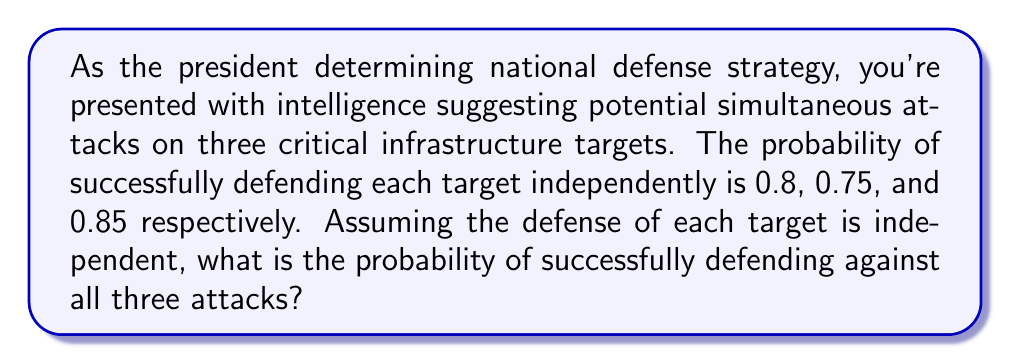Teach me how to tackle this problem. To solve this problem, we need to follow these steps:

1. Identify the given probabilities:
   - Target 1: $P(D_1) = 0.8$
   - Target 2: $P(D_2) = 0.75$
   - Target 3: $P(D_3) = 0.85$

   Where $D_i$ represents the event of successfully defending target $i$.

2. Since we need to calculate the probability of successfully defending all three targets, and the events are independent, we can use the multiplication rule of probability.

3. The probability of all three events occurring simultaneously is:

   $$P(D_1 \cap D_2 \cap D_3) = P(D_1) \times P(D_2) \times P(D_3)$$

4. Substituting the given probabilities:

   $$P(D_1 \cap D_2 \cap D_3) = 0.8 \times 0.75 \times 0.85$$

5. Calculating the result:

   $$P(D_1 \cap D_2 \cap D_3) = 0.51$$

Therefore, the probability of successfully defending against all three attacks simultaneously is 0.51 or 51%.
Answer: 0.51 